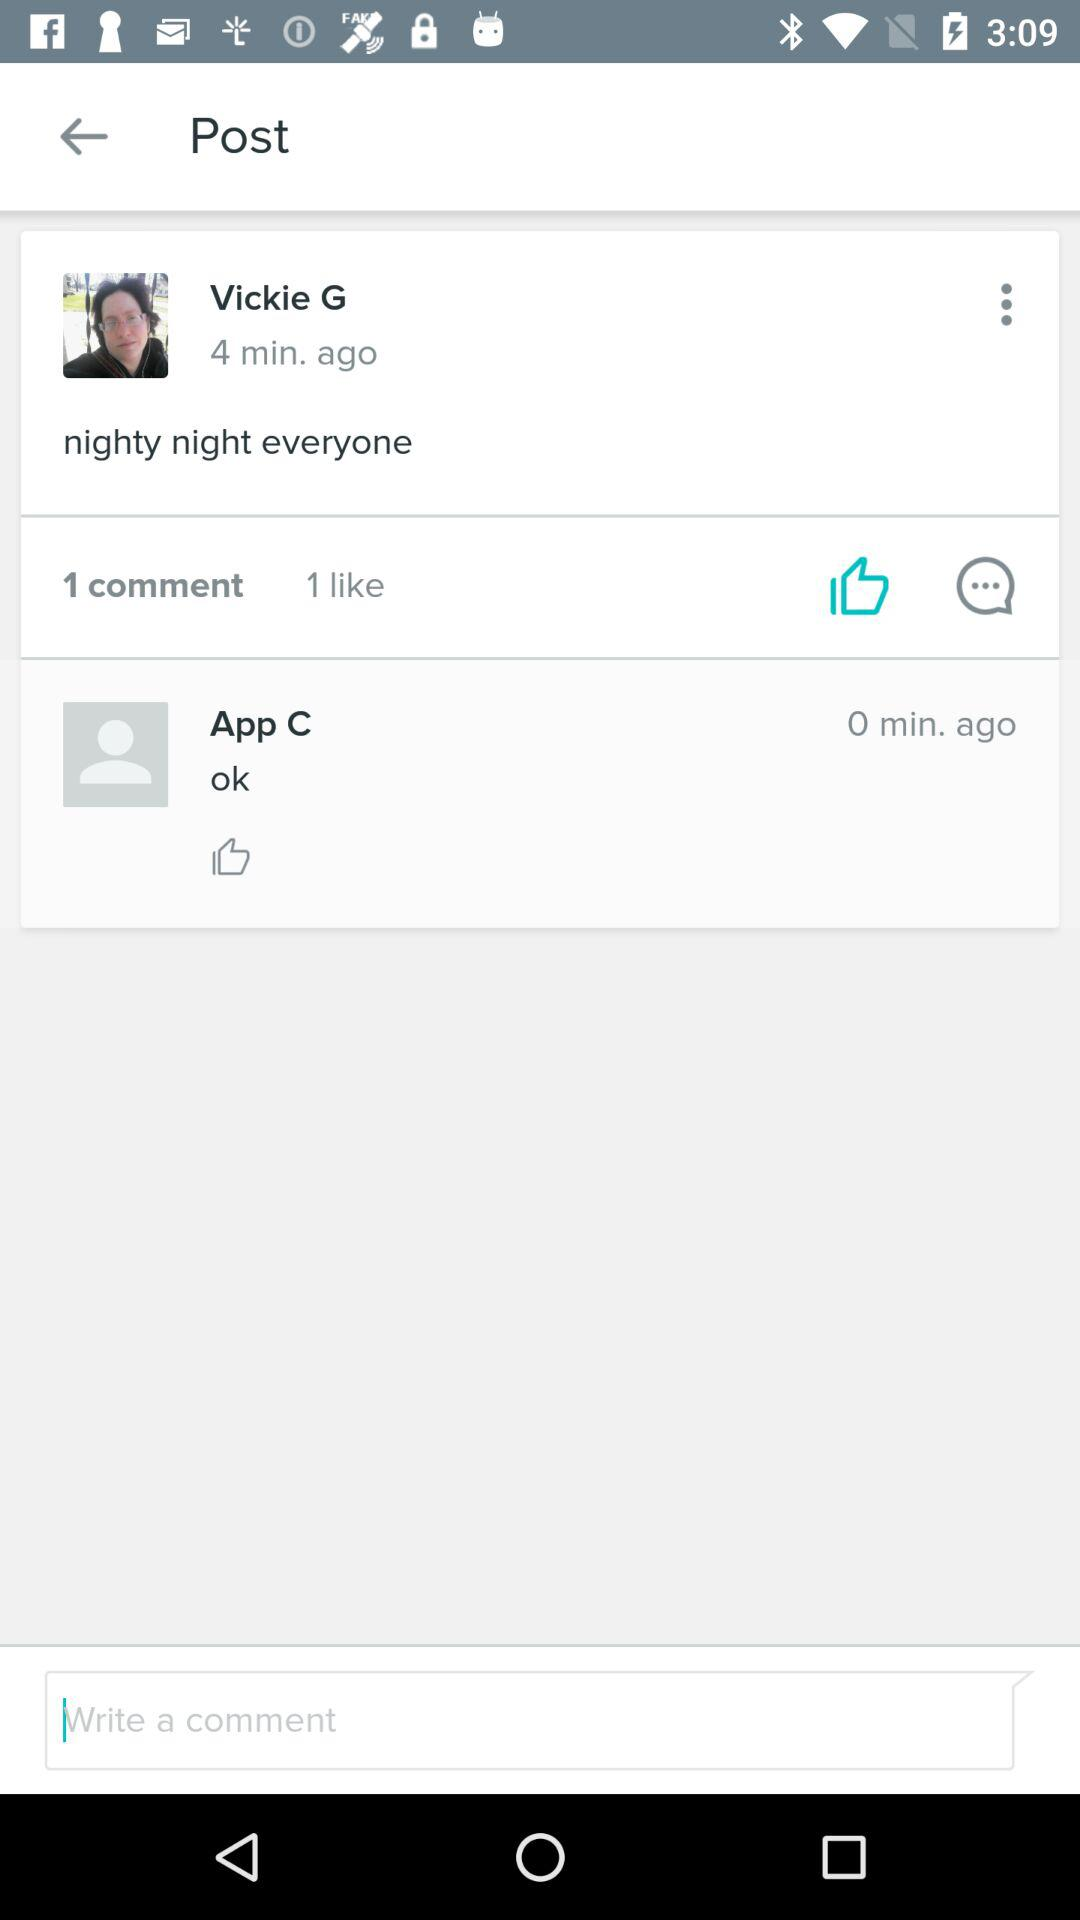How many people have commented? There is 1 person who commented. 